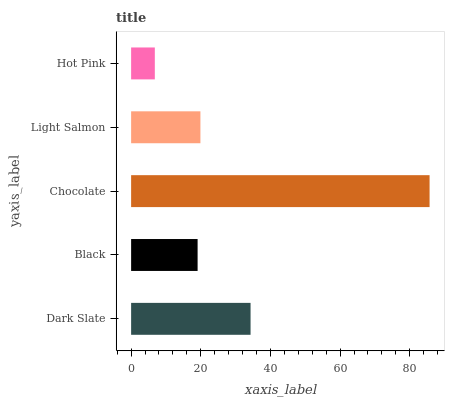Is Hot Pink the minimum?
Answer yes or no. Yes. Is Chocolate the maximum?
Answer yes or no. Yes. Is Black the minimum?
Answer yes or no. No. Is Black the maximum?
Answer yes or no. No. Is Dark Slate greater than Black?
Answer yes or no. Yes. Is Black less than Dark Slate?
Answer yes or no. Yes. Is Black greater than Dark Slate?
Answer yes or no. No. Is Dark Slate less than Black?
Answer yes or no. No. Is Light Salmon the high median?
Answer yes or no. Yes. Is Light Salmon the low median?
Answer yes or no. Yes. Is Chocolate the high median?
Answer yes or no. No. Is Black the low median?
Answer yes or no. No. 